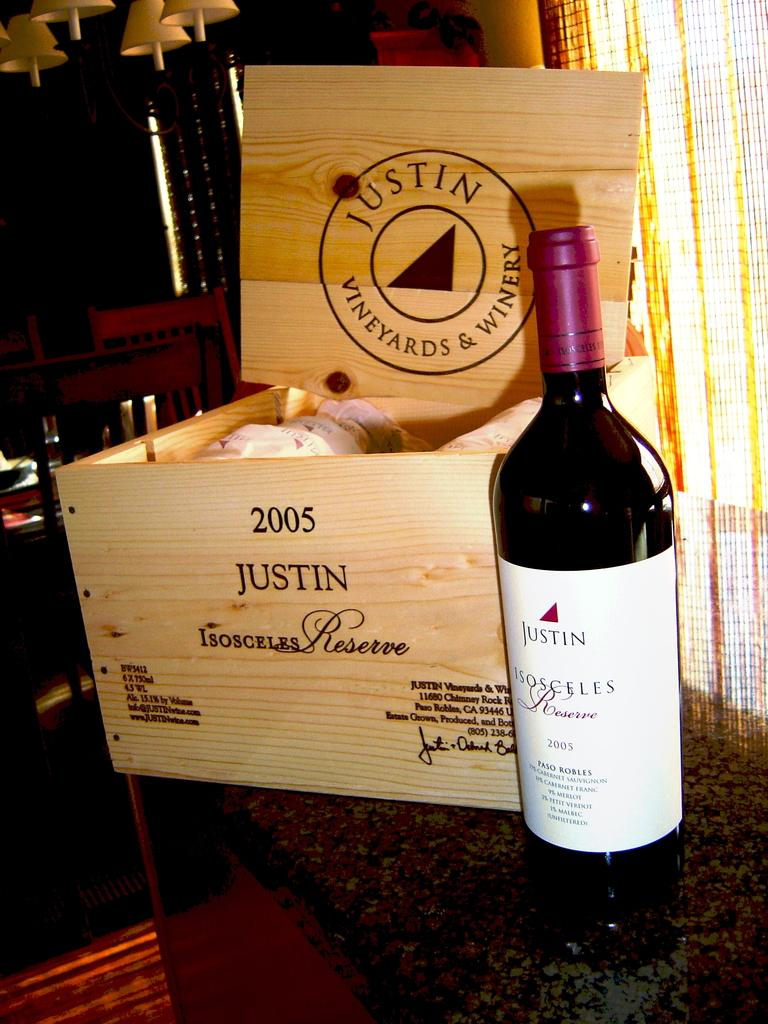<image>
Relay a brief, clear account of the picture shown. a box of wine bottles from JUSTIN VINEYARDS & WINERY 2005 ISOCELES Reserve and a bottle of the wine next to it. 